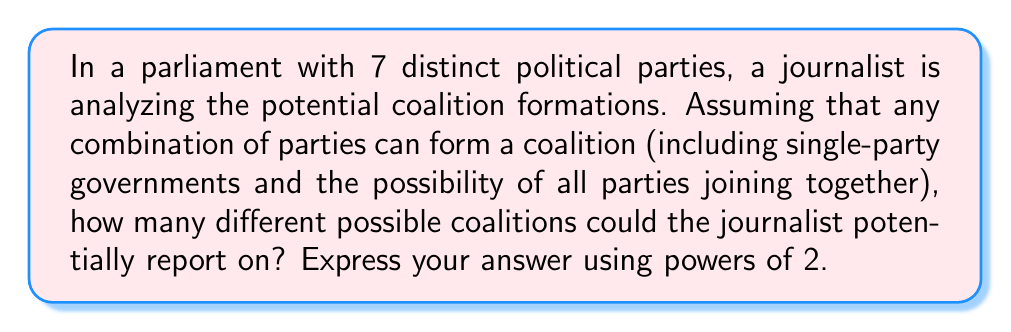Can you solve this math problem? Let's approach this step-by-step:

1) In this scenario, each party has two options: it can either be in the coalition or not be in the coalition.

2) This is a classic application of the multiplication principle in combinatorics.

3) For each party, we have 2 choices (in or out), and we have 7 parties in total.

4) Therefore, the total number of possible coalitions is:

   $$ 2 \times 2 \times 2 \times 2 \times 2 \times 2 \times 2 = 2^7 $$

5) This includes all possible combinations:
   - The empty set (no parties in the coalition, which isn't a real coalition but is counted in this mathematical model)
   - All 7 single-party "coalitions"
   - All possible multi-party coalitions
   - The grand coalition of all 7 parties

6) In terms of political reporting, this means the journalist would have $2^7 - 1 = 127$ actual coalitions to potentially report on (subtracting the empty set).
Answer: $2^7$ or 128 